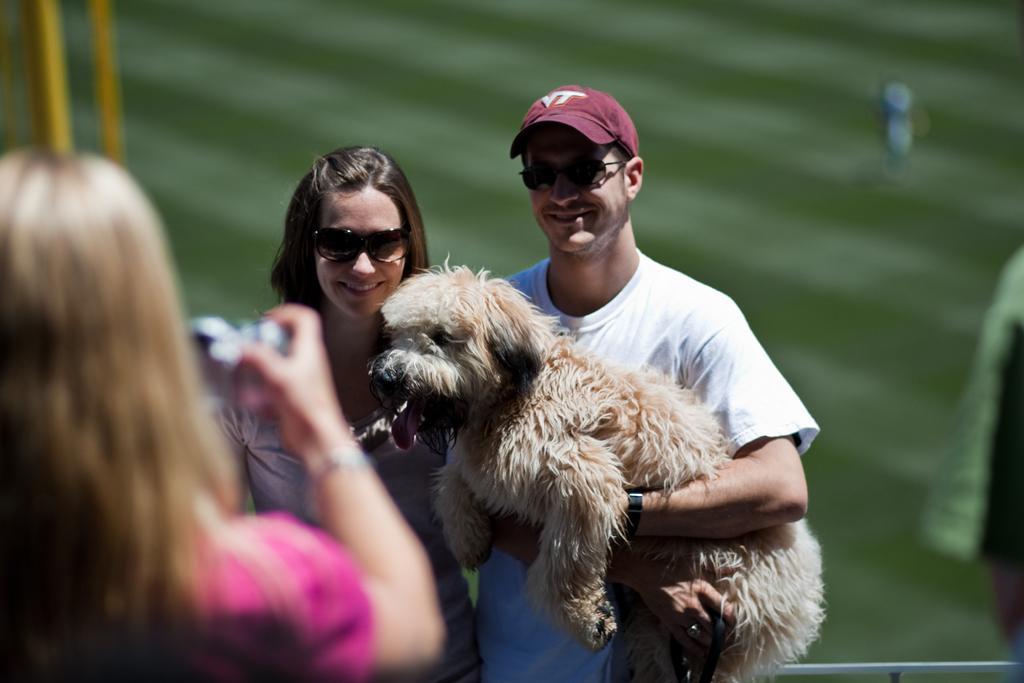Please provide a concise description of this image. In this image I can see a man white color t-shirt and red color cap on his head and smiling. In his hands there is a dog. Beside this person there is a woman standing and smiling. The man and woman are looking at the camera. On the left side of the image there is a woman wearing pink color dress and holding the camera in her hands. 